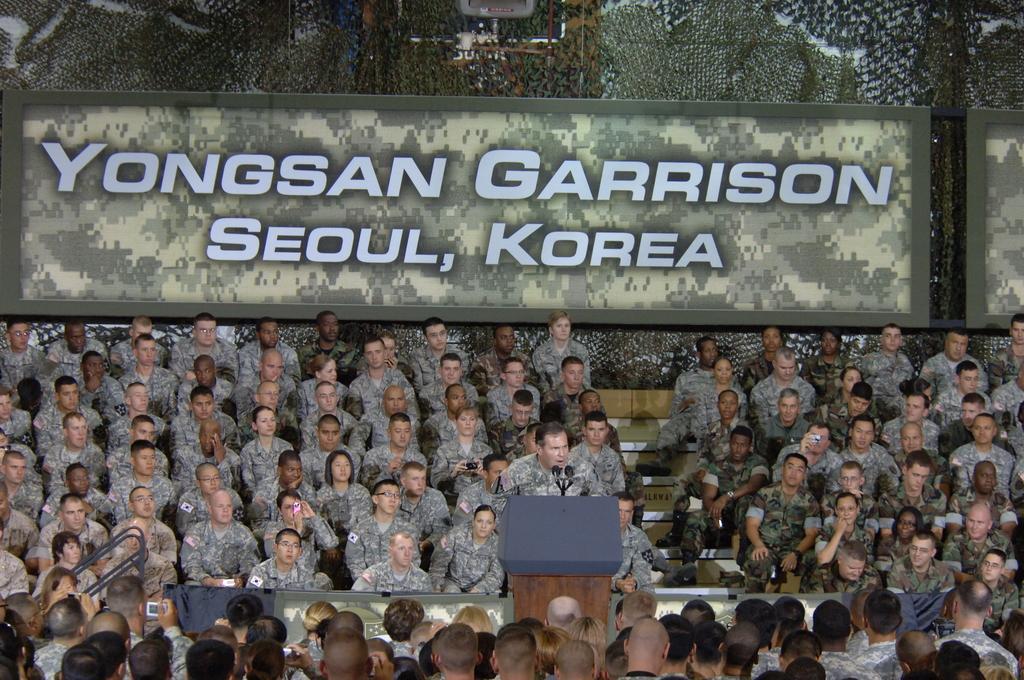Describe this image in one or two sentences. In this image, we can see a few people. Among them, some people are sitting. We can also see a board with some text. We can see the podium and a few microphones. We can also see an object in the background. We can see the fence. 